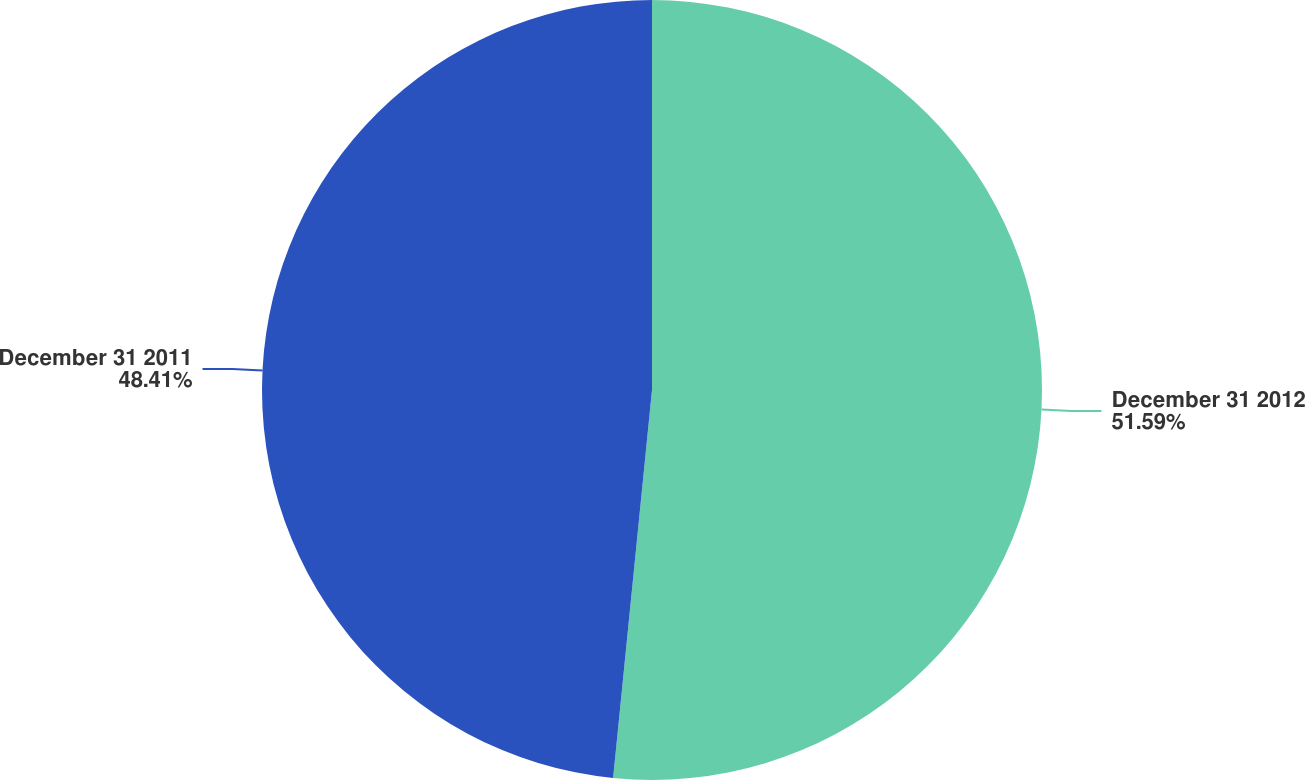<chart> <loc_0><loc_0><loc_500><loc_500><pie_chart><fcel>December 31 2012<fcel>December 31 2011<nl><fcel>51.59%<fcel>48.41%<nl></chart> 